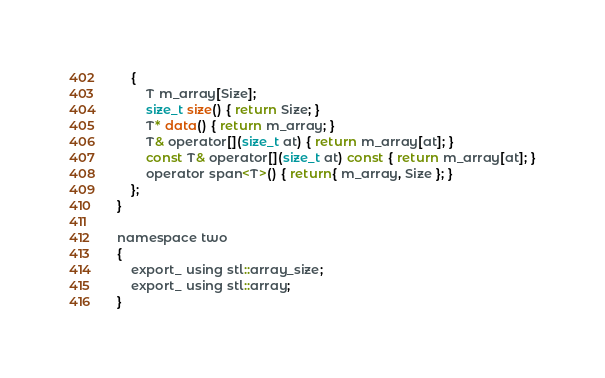Convert code to text. <code><loc_0><loc_0><loc_500><loc_500><_C_>	{
		T m_array[Size];
		size_t size() { return Size; }
		T* data() { return m_array; }
		T& operator[](size_t at) { return m_array[at]; }
		const T& operator[](size_t at) const { return m_array[at]; }
		operator span<T>() { return{ m_array, Size }; }
	};
}

namespace two
{
	export_ using stl::array_size;
	export_ using stl::array;
}
</code> 